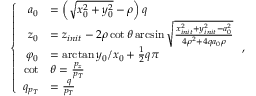Convert formula to latex. <formula><loc_0><loc_0><loc_500><loc_500>\left \{ \begin{array} { r l } { a _ { 0 } } & { = \left ( \sqrt { x _ { 0 } ^ { 2 } + y _ { 0 } ^ { 2 } } - \rho \right ) q } \\ { z _ { 0 } } & { = z _ { i n i t } - 2 \rho \cot { \theta } \arcsin { \sqrt { \frac { x _ { i n i t } ^ { 2 } + y _ { i n i t } ^ { 2 } - a _ { 0 } ^ { 2 } } { 4 \rho ^ { 2 } + 4 q a _ { 0 } \rho } } } } \\ { \varphi _ { 0 } } & { = \arctan { y _ { 0 } / x _ { 0 } } + \frac { 1 } { 2 } q \pi } \\ { \cot } & { \theta = \frac { p _ { z } } { p _ { T } } } \\ { q _ { p _ { T } } } & { = \frac { q } { p _ { T } } } \end{array} ,</formula> 